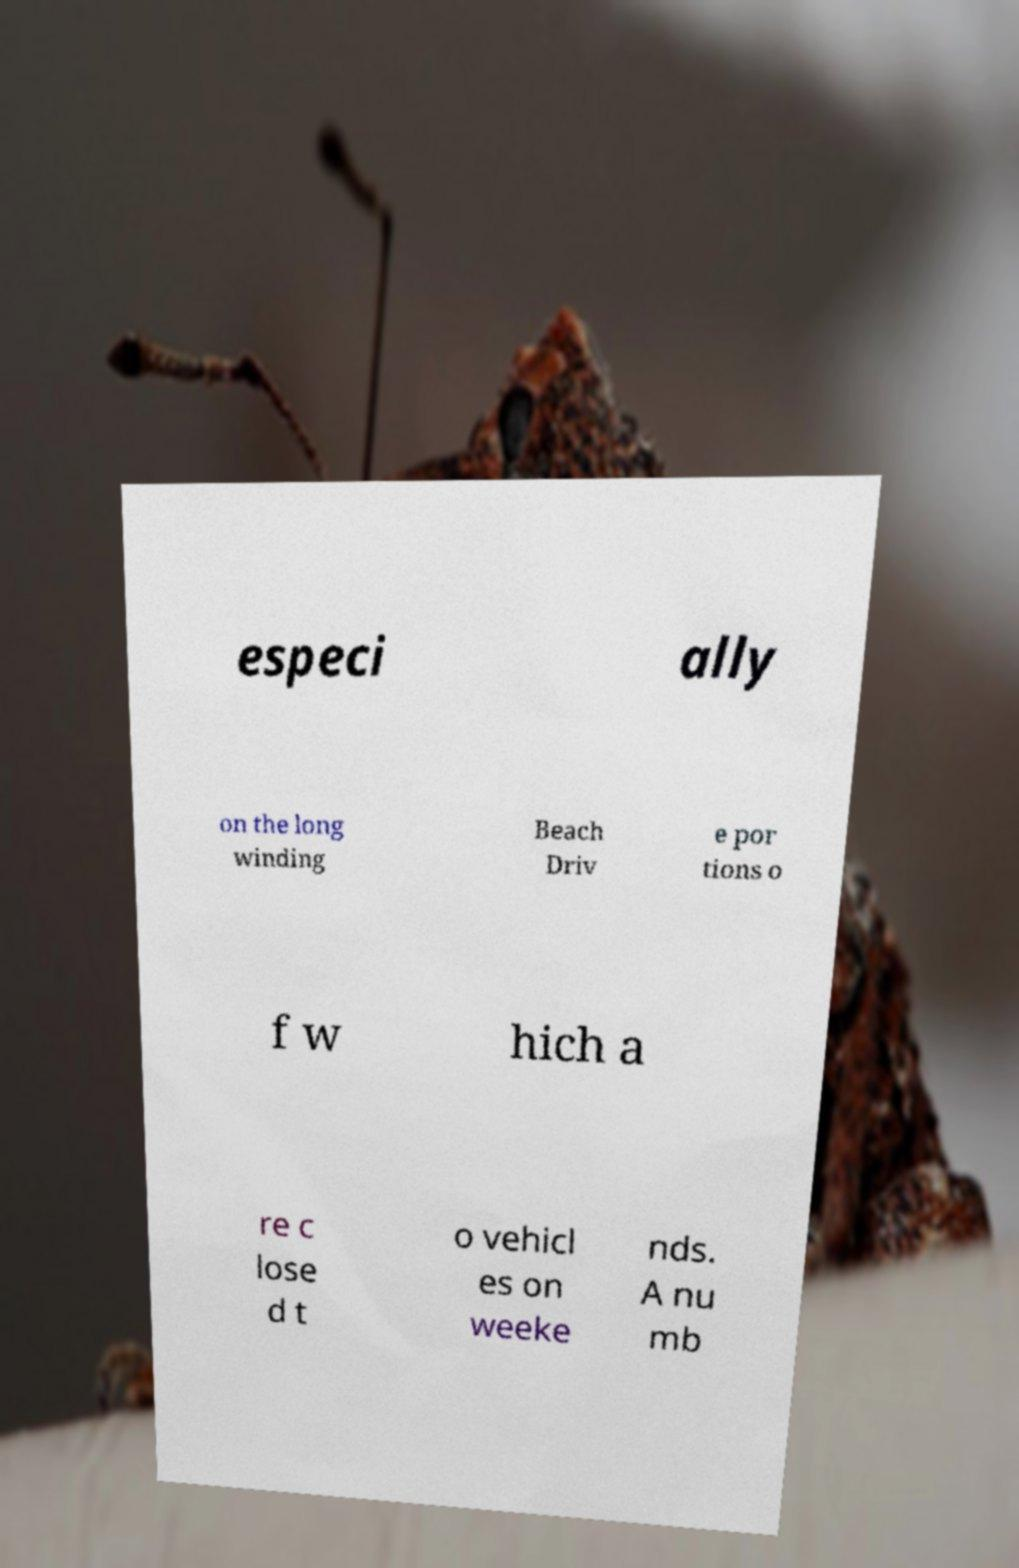For documentation purposes, I need the text within this image transcribed. Could you provide that? especi ally on the long winding Beach Driv e por tions o f w hich a re c lose d t o vehicl es on weeke nds. A nu mb 